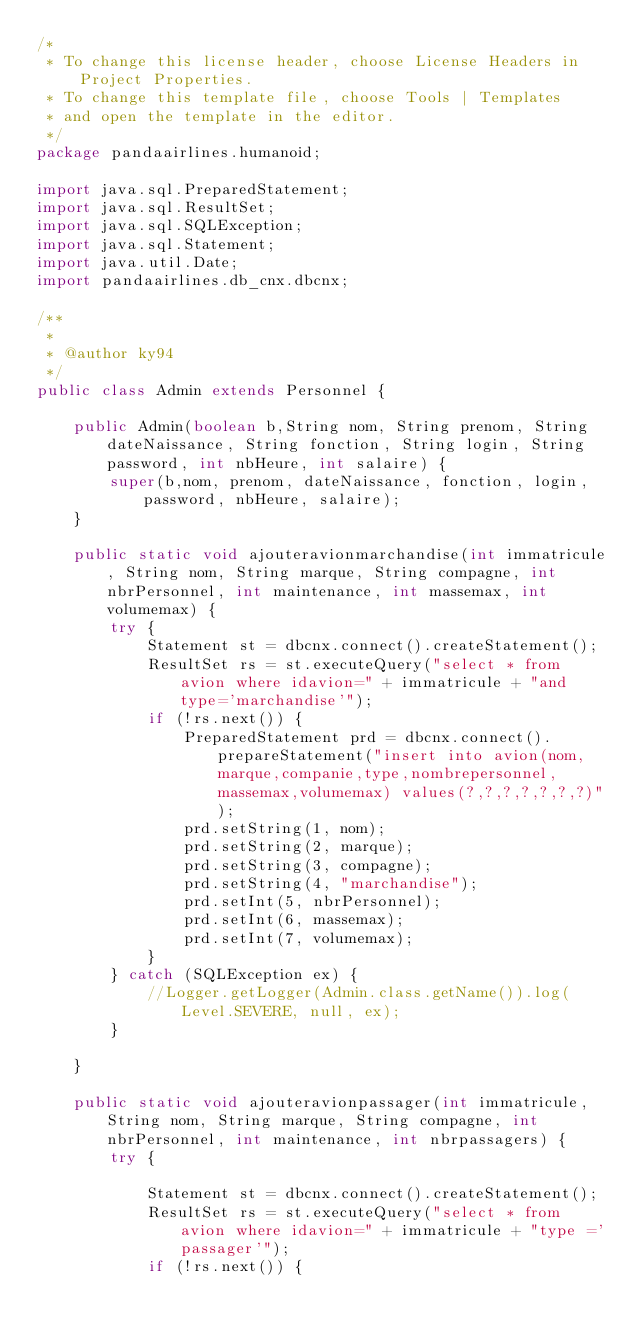<code> <loc_0><loc_0><loc_500><loc_500><_Java_>/*
 * To change this license header, choose License Headers in Project Properties.
 * To change this template file, choose Tools | Templates
 * and open the template in the editor.
 */
package pandaairlines.humanoid;

import java.sql.PreparedStatement;
import java.sql.ResultSet;
import java.sql.SQLException;
import java.sql.Statement;
import java.util.Date;
import pandaairlines.db_cnx.dbcnx;

/**
 *
 * @author ky94
 */
public class Admin extends Personnel {

    public Admin(boolean b,String nom, String prenom, String dateNaissance, String fonction, String login, String password, int nbHeure, int salaire) {
        super(b,nom, prenom, dateNaissance, fonction, login, password, nbHeure, salaire);
    }

    public static void ajouteravionmarchandise(int immatricule, String nom, String marque, String compagne, int nbrPersonnel, int maintenance, int massemax, int volumemax) {
        try {
            Statement st = dbcnx.connect().createStatement();
            ResultSet rs = st.executeQuery("select * from avion where idavion=" + immatricule + "and type='marchandise'");
            if (!rs.next()) {
                PreparedStatement prd = dbcnx.connect().prepareStatement("insert into avion(nom,marque,companie,type,nombrepersonnel,massemax,volumemax) values(?,?,?,?,?,?,?)");
                prd.setString(1, nom);
                prd.setString(2, marque);
                prd.setString(3, compagne);
                prd.setString(4, "marchandise");
                prd.setInt(5, nbrPersonnel);
                prd.setInt(6, massemax);
                prd.setInt(7, volumemax);
            }
        } catch (SQLException ex) {
            //Logger.getLogger(Admin.class.getName()).log(Level.SEVERE, null, ex);
        }

    }

    public static void ajouteravionpassager(int immatricule, String nom, String marque, String compagne, int nbrPersonnel, int maintenance, int nbrpassagers) {
        try {

            Statement st = dbcnx.connect().createStatement();
            ResultSet rs = st.executeQuery("select * from avion where idavion=" + immatricule + "type ='passager'");
            if (!rs.next()) {</code> 